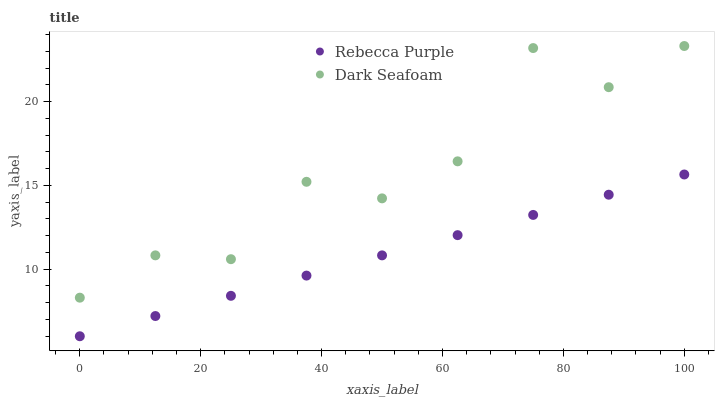Does Rebecca Purple have the minimum area under the curve?
Answer yes or no. Yes. Does Dark Seafoam have the maximum area under the curve?
Answer yes or no. Yes. Does Rebecca Purple have the maximum area under the curve?
Answer yes or no. No. Is Rebecca Purple the smoothest?
Answer yes or no. Yes. Is Dark Seafoam the roughest?
Answer yes or no. Yes. Is Rebecca Purple the roughest?
Answer yes or no. No. Does Rebecca Purple have the lowest value?
Answer yes or no. Yes. Does Dark Seafoam have the highest value?
Answer yes or no. Yes. Does Rebecca Purple have the highest value?
Answer yes or no. No. Is Rebecca Purple less than Dark Seafoam?
Answer yes or no. Yes. Is Dark Seafoam greater than Rebecca Purple?
Answer yes or no. Yes. Does Rebecca Purple intersect Dark Seafoam?
Answer yes or no. No. 